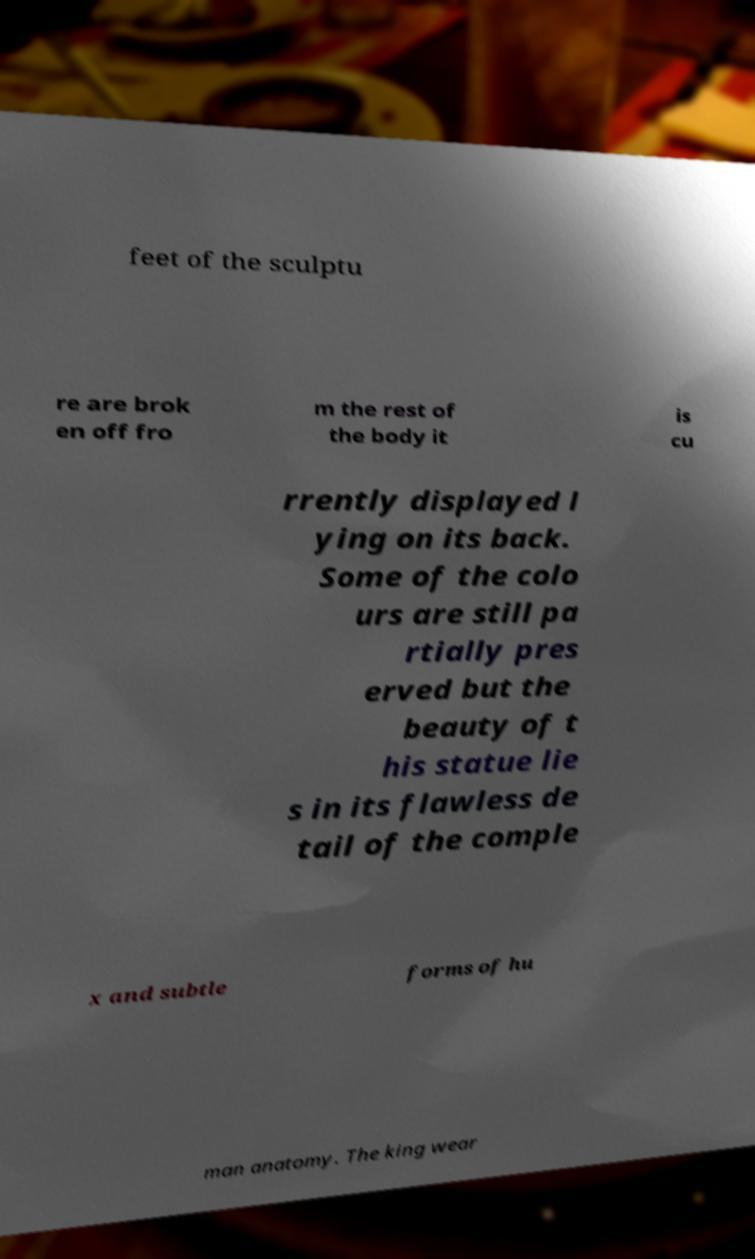Can you accurately transcribe the text from the provided image for me? feet of the sculptu re are brok en off fro m the rest of the body it is cu rrently displayed l ying on its back. Some of the colo urs are still pa rtially pres erved but the beauty of t his statue lie s in its flawless de tail of the comple x and subtle forms of hu man anatomy. The king wear 